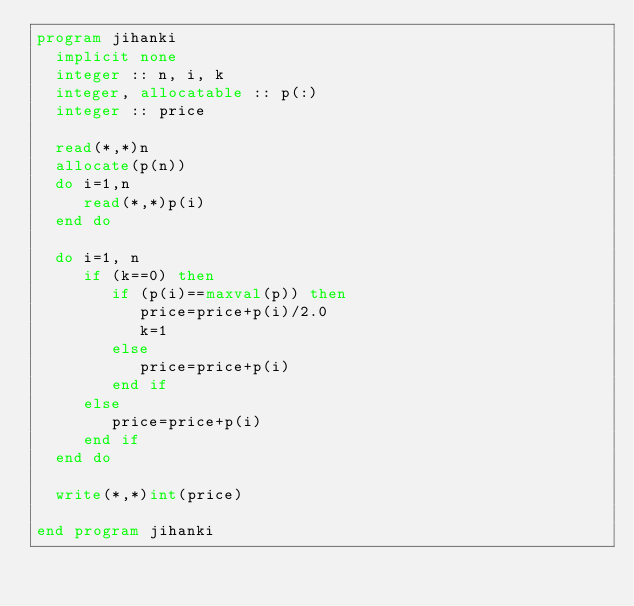<code> <loc_0><loc_0><loc_500><loc_500><_FORTRAN_>program jihanki
  implicit none
  integer :: n, i, k
  integer, allocatable :: p(:)
  integer :: price

  read(*,*)n
  allocate(p(n))
  do i=1,n
     read(*,*)p(i)
  end do

  do i=1, n
     if (k==0) then
        if (p(i)==maxval(p)) then
           price=price+p(i)/2.0
           k=1
        else
           price=price+p(i)
        end if
     else
        price=price+p(i)
     end if
  end do

  write(*,*)int(price)
  
end program jihanki
</code> 